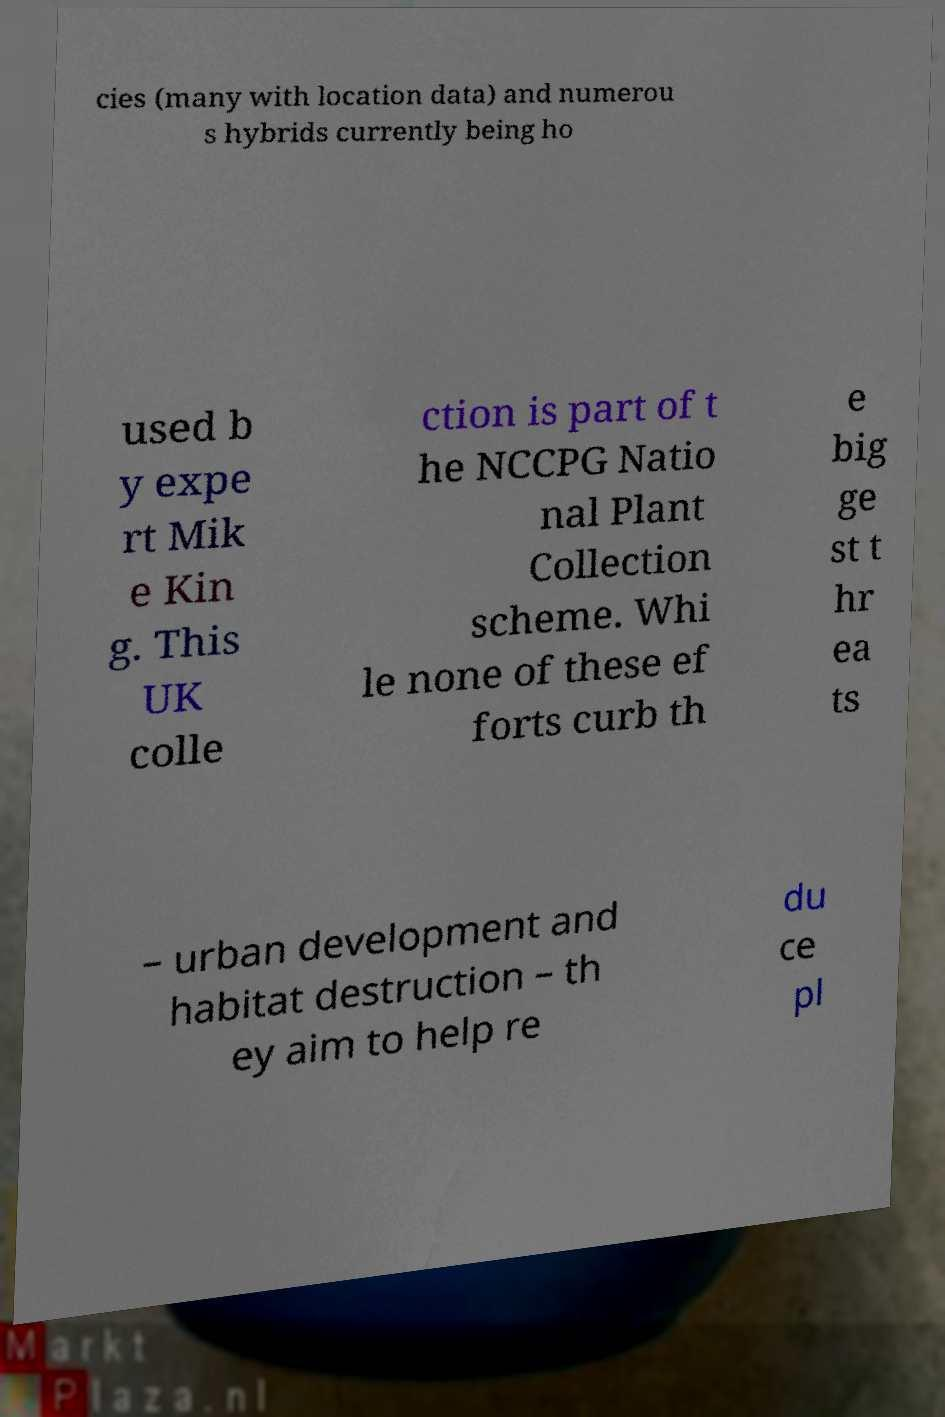Please read and relay the text visible in this image. What does it say? cies (many with location data) and numerou s hybrids currently being ho used b y expe rt Mik e Kin g. This UK colle ction is part of t he NCCPG Natio nal Plant Collection scheme. Whi le none of these ef forts curb th e big ge st t hr ea ts – urban development and habitat destruction – th ey aim to help re du ce pl 